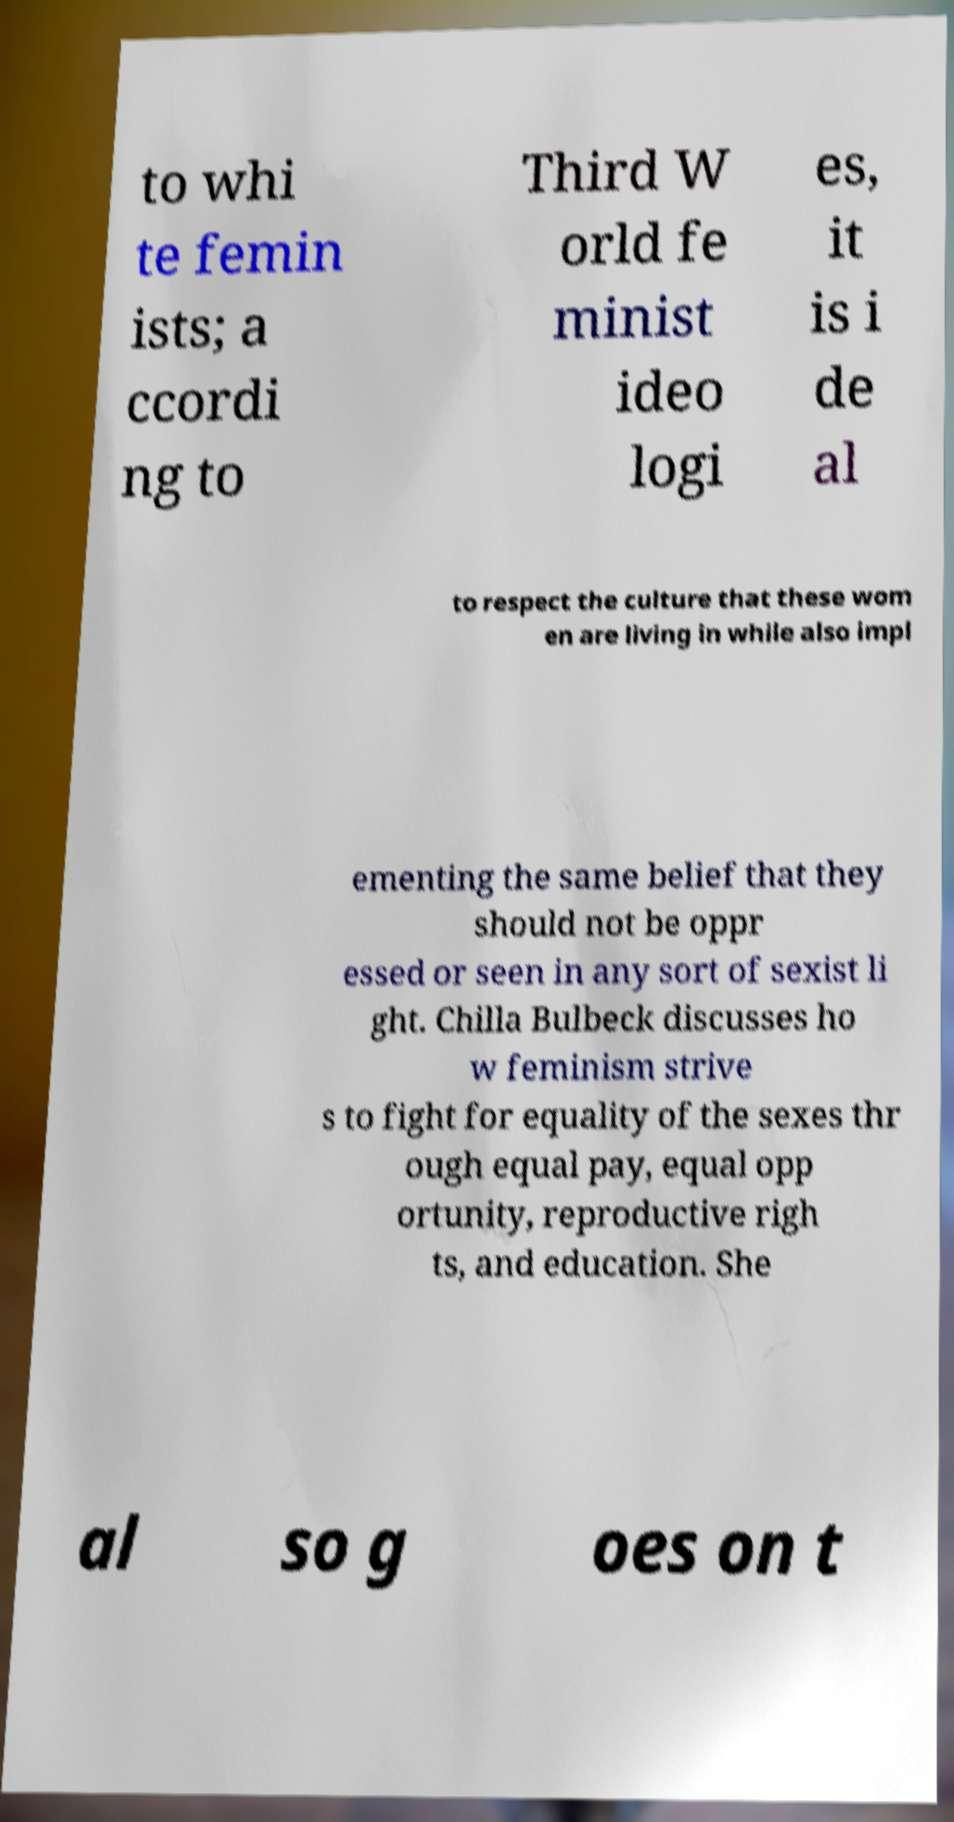There's text embedded in this image that I need extracted. Can you transcribe it verbatim? to whi te femin ists; a ccordi ng to Third W orld fe minist ideo logi es, it is i de al to respect the culture that these wom en are living in while also impl ementing the same belief that they should not be oppr essed or seen in any sort of sexist li ght. Chilla Bulbeck discusses ho w feminism strive s to fight for equality of the sexes thr ough equal pay, equal opp ortunity, reproductive righ ts, and education. She al so g oes on t 